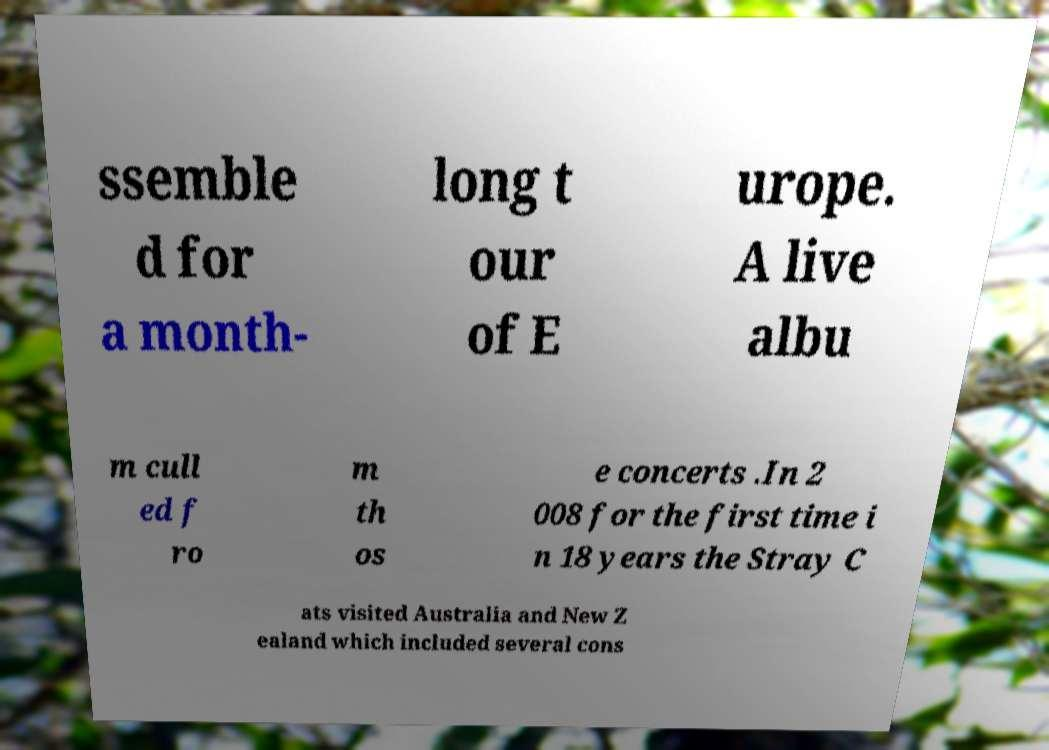There's text embedded in this image that I need extracted. Can you transcribe it verbatim? ssemble d for a month- long t our of E urope. A live albu m cull ed f ro m th os e concerts .In 2 008 for the first time i n 18 years the Stray C ats visited Australia and New Z ealand which included several cons 